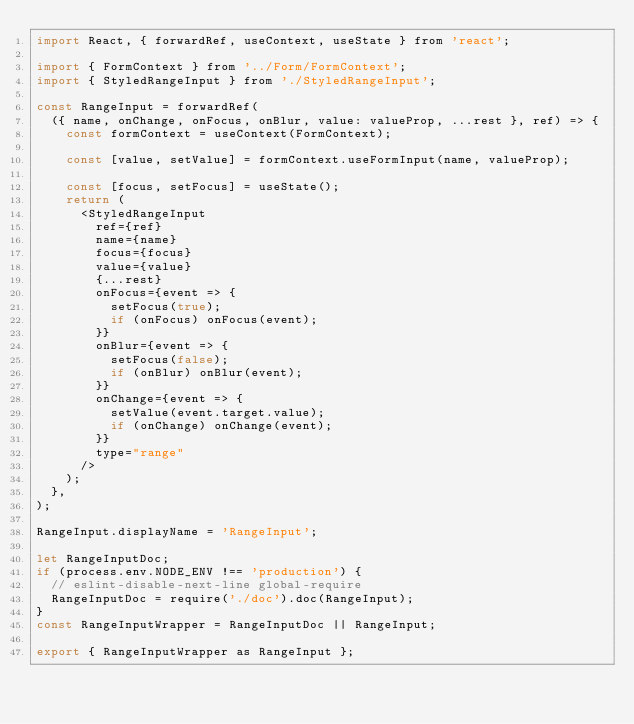Convert code to text. <code><loc_0><loc_0><loc_500><loc_500><_JavaScript_>import React, { forwardRef, useContext, useState } from 'react';

import { FormContext } from '../Form/FormContext';
import { StyledRangeInput } from './StyledRangeInput';

const RangeInput = forwardRef(
  ({ name, onChange, onFocus, onBlur, value: valueProp, ...rest }, ref) => {
    const formContext = useContext(FormContext);

    const [value, setValue] = formContext.useFormInput(name, valueProp);

    const [focus, setFocus] = useState();
    return (
      <StyledRangeInput
        ref={ref}
        name={name}
        focus={focus}
        value={value}
        {...rest}
        onFocus={event => {
          setFocus(true);
          if (onFocus) onFocus(event);
        }}
        onBlur={event => {
          setFocus(false);
          if (onBlur) onBlur(event);
        }}
        onChange={event => {
          setValue(event.target.value);
          if (onChange) onChange(event);
        }}
        type="range"
      />
    );
  },
);

RangeInput.displayName = 'RangeInput';

let RangeInputDoc;
if (process.env.NODE_ENV !== 'production') {
  // eslint-disable-next-line global-require
  RangeInputDoc = require('./doc').doc(RangeInput);
}
const RangeInputWrapper = RangeInputDoc || RangeInput;

export { RangeInputWrapper as RangeInput };
</code> 